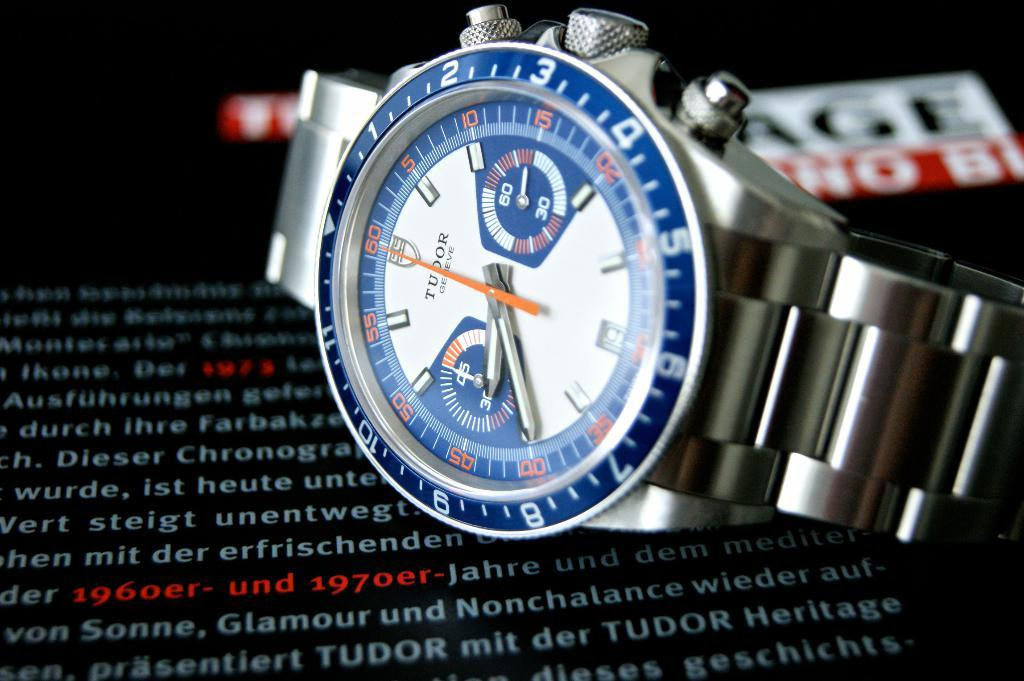<image>
Present a compact description of the photo's key features. A Tudor watched on it's side on top of some advertisement for it. 